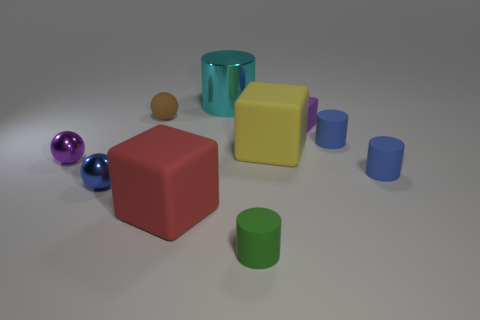There is a metallic object right of the blue metallic object; is it the same size as the tiny blue metallic thing?
Give a very brief answer. No. There is a purple thing left of the large cyan metallic cylinder; what is it made of?
Give a very brief answer. Metal. Are there the same number of purple cubes in front of the blue shiny object and blue rubber cylinders that are to the left of the small purple shiny ball?
Make the answer very short. Yes. There is another large object that is the same shape as the green thing; what is its color?
Your answer should be compact. Cyan. Is there any other thing that has the same color as the big cylinder?
Offer a terse response. No. What number of metal objects are big yellow objects or cylinders?
Offer a terse response. 1. Does the large cylinder have the same color as the tiny rubber cube?
Keep it short and to the point. No. Are there more blue matte cylinders to the left of the cyan shiny thing than small green metallic spheres?
Make the answer very short. No. What number of other things are there of the same material as the big yellow cube
Give a very brief answer. 6. How many large objects are purple spheres or green rubber balls?
Make the answer very short. 0. 